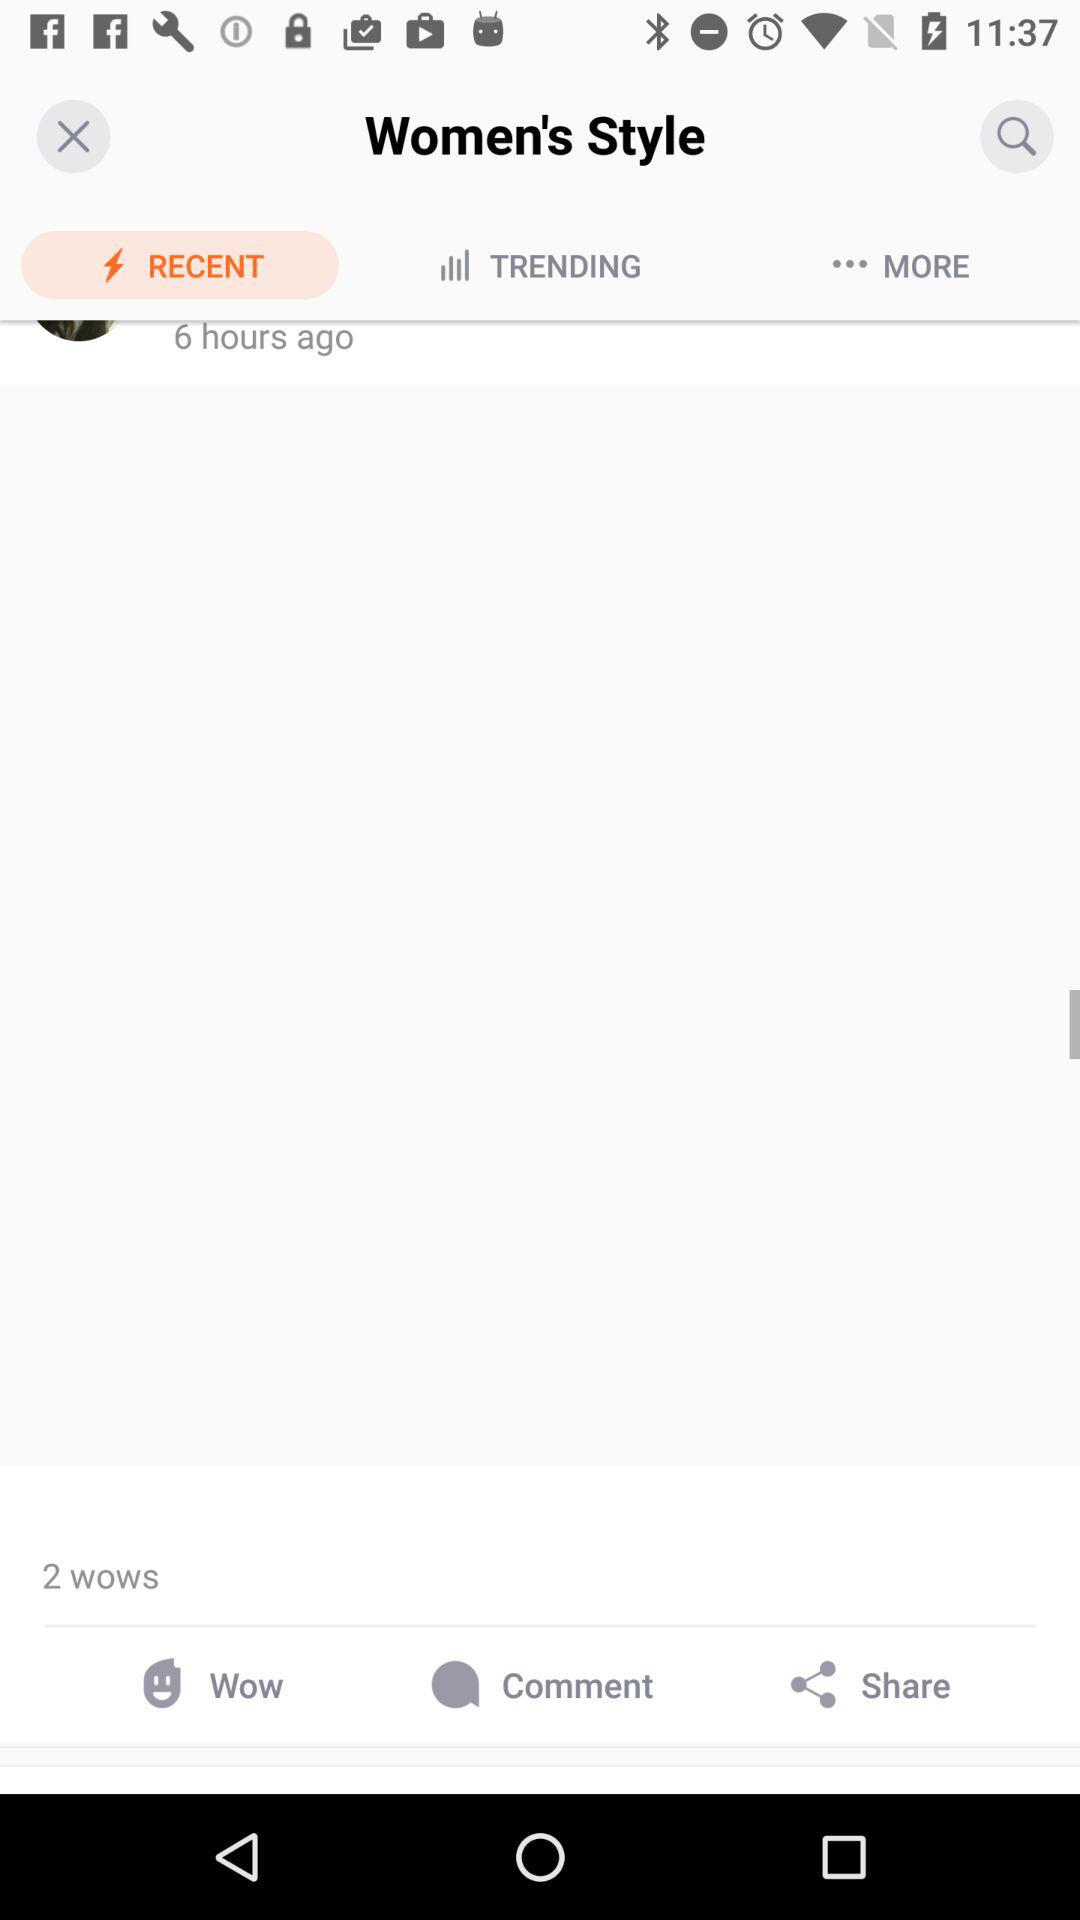How many more wows than comments are there?
Answer the question using a single word or phrase. 2 